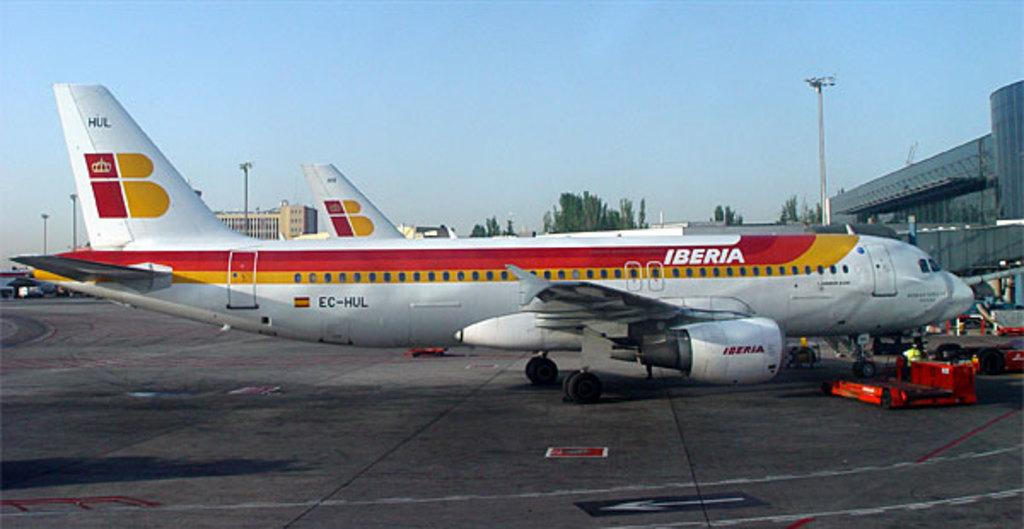<image>
Describe the image concisely. An Iberia plane with red and orange stripes sitting on a runway 